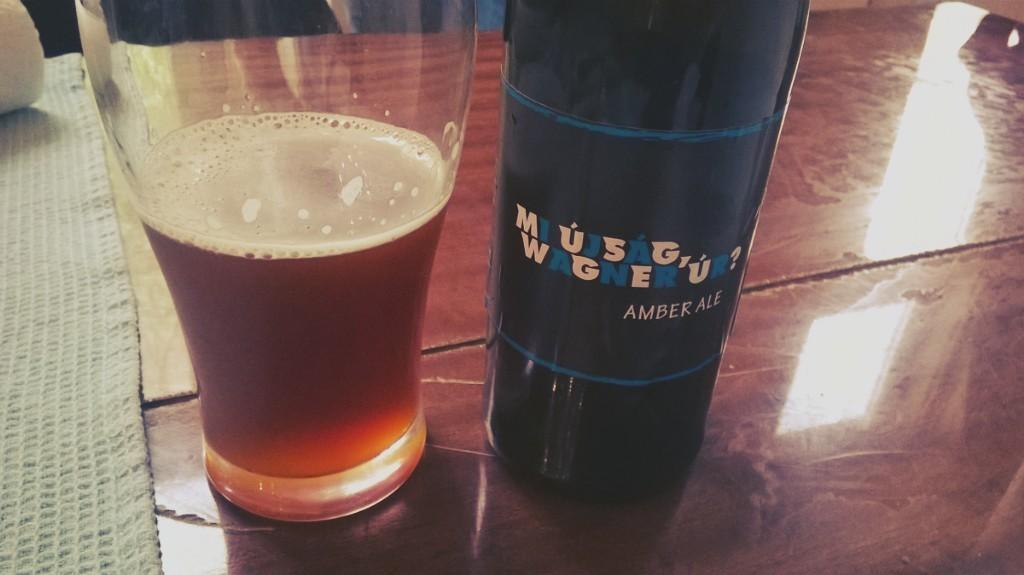<image>
Relay a brief, clear account of the picture shown. A glass full of beeer is sitting next to a bottle with the name Amber Ale on it. 